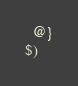<code> <loc_0><loc_0><loc_500><loc_500><_ObjectiveC_>  @}
$)
</code> 